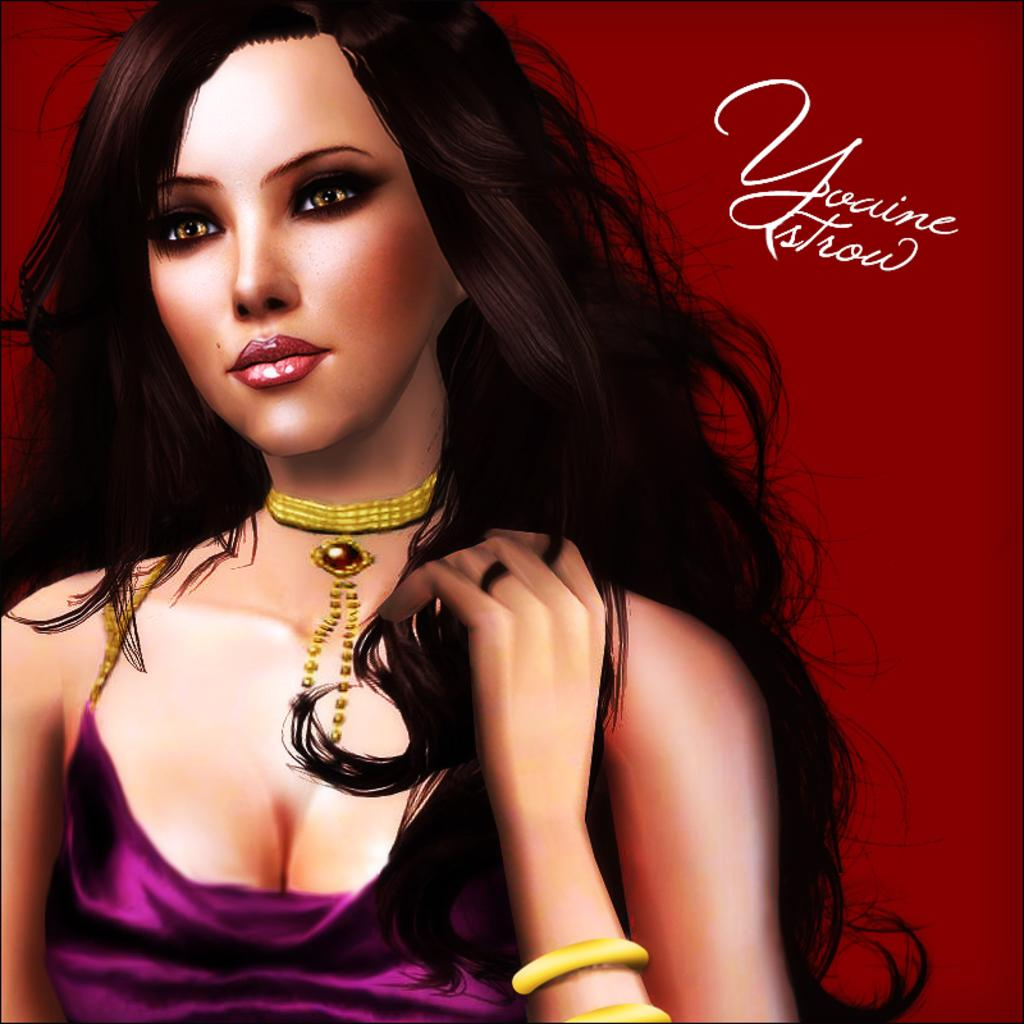What type of image is depicted in the picture? There is an animated image of a woman in the picture. Where is the text located in the picture? The text is in the top right corner of the picture. What type of soup is the woman eating in the image? There is no soup present in the image; it features an animated image of a woman and text in the top right corner. 